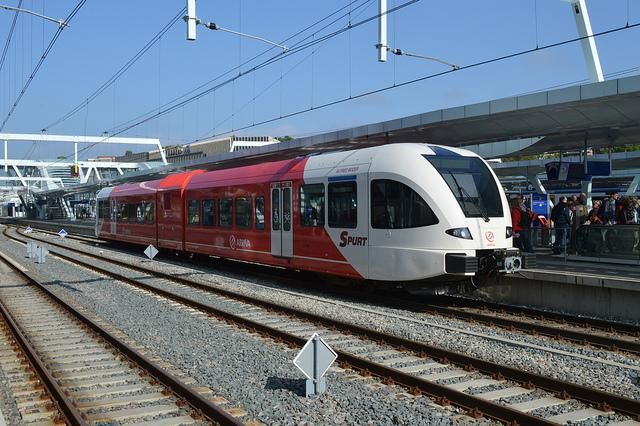What type power does this train use?

Choices:
A) gas
B) diesel
C) coal
D) electrical electrical 